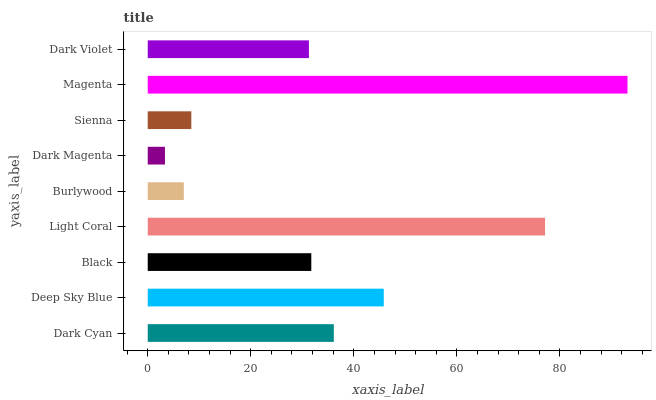Is Dark Magenta the minimum?
Answer yes or no. Yes. Is Magenta the maximum?
Answer yes or no. Yes. Is Deep Sky Blue the minimum?
Answer yes or no. No. Is Deep Sky Blue the maximum?
Answer yes or no. No. Is Deep Sky Blue greater than Dark Cyan?
Answer yes or no. Yes. Is Dark Cyan less than Deep Sky Blue?
Answer yes or no. Yes. Is Dark Cyan greater than Deep Sky Blue?
Answer yes or no. No. Is Deep Sky Blue less than Dark Cyan?
Answer yes or no. No. Is Black the high median?
Answer yes or no. Yes. Is Black the low median?
Answer yes or no. Yes. Is Dark Violet the high median?
Answer yes or no. No. Is Dark Violet the low median?
Answer yes or no. No. 